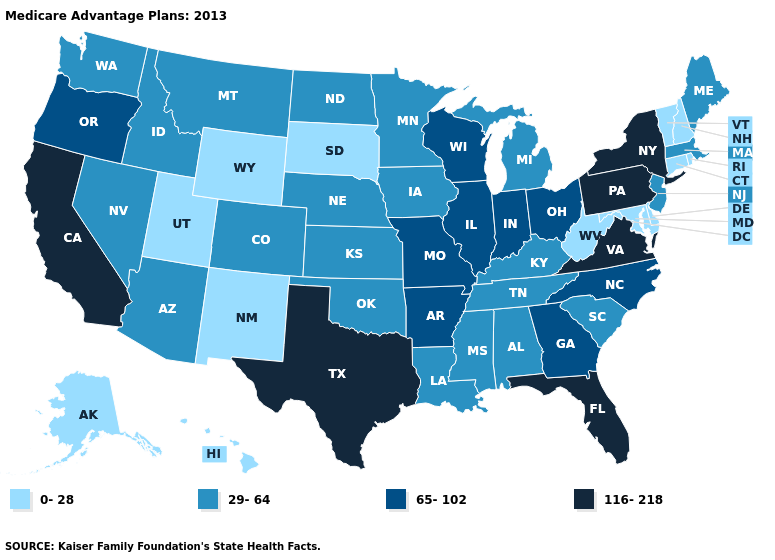What is the highest value in states that border Arizona?
Short answer required. 116-218. Name the states that have a value in the range 0-28?
Short answer required. Alaska, Connecticut, Delaware, Hawaii, Maryland, New Hampshire, New Mexico, Rhode Island, South Dakota, Utah, Vermont, West Virginia, Wyoming. What is the value of North Carolina?
Concise answer only. 65-102. Does the map have missing data?
Concise answer only. No. Name the states that have a value in the range 65-102?
Concise answer only. Arkansas, Georgia, Illinois, Indiana, Missouri, North Carolina, Ohio, Oregon, Wisconsin. Among the states that border Mississippi , which have the lowest value?
Answer briefly. Alabama, Louisiana, Tennessee. What is the highest value in states that border Maryland?
Concise answer only. 116-218. Name the states that have a value in the range 29-64?
Concise answer only. Alabama, Arizona, Colorado, Iowa, Idaho, Kansas, Kentucky, Louisiana, Massachusetts, Maine, Michigan, Minnesota, Mississippi, Montana, North Dakota, Nebraska, New Jersey, Nevada, Oklahoma, South Carolina, Tennessee, Washington. What is the lowest value in states that border Idaho?
Concise answer only. 0-28. Name the states that have a value in the range 0-28?
Keep it brief. Alaska, Connecticut, Delaware, Hawaii, Maryland, New Hampshire, New Mexico, Rhode Island, South Dakota, Utah, Vermont, West Virginia, Wyoming. What is the value of Delaware?
Write a very short answer. 0-28. What is the lowest value in the USA?
Answer briefly. 0-28. What is the value of New Jersey?
Keep it brief. 29-64. Name the states that have a value in the range 65-102?
Concise answer only. Arkansas, Georgia, Illinois, Indiana, Missouri, North Carolina, Ohio, Oregon, Wisconsin. 